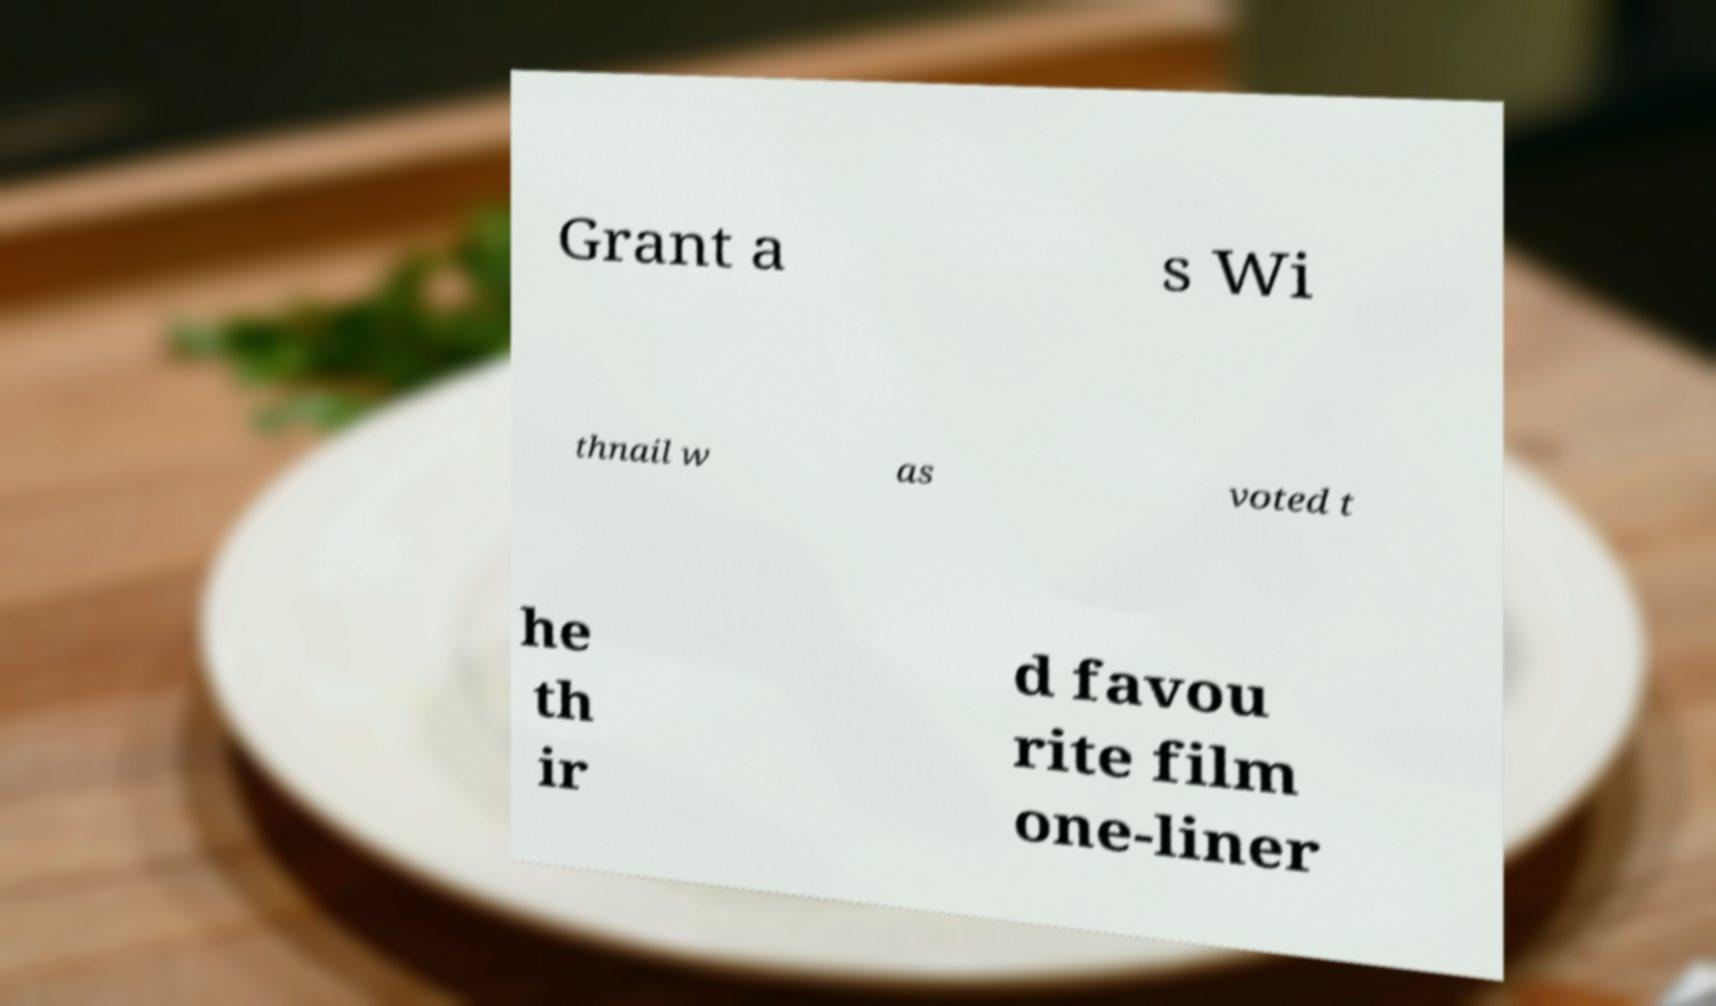There's text embedded in this image that I need extracted. Can you transcribe it verbatim? Grant a s Wi thnail w as voted t he th ir d favou rite film one-liner 